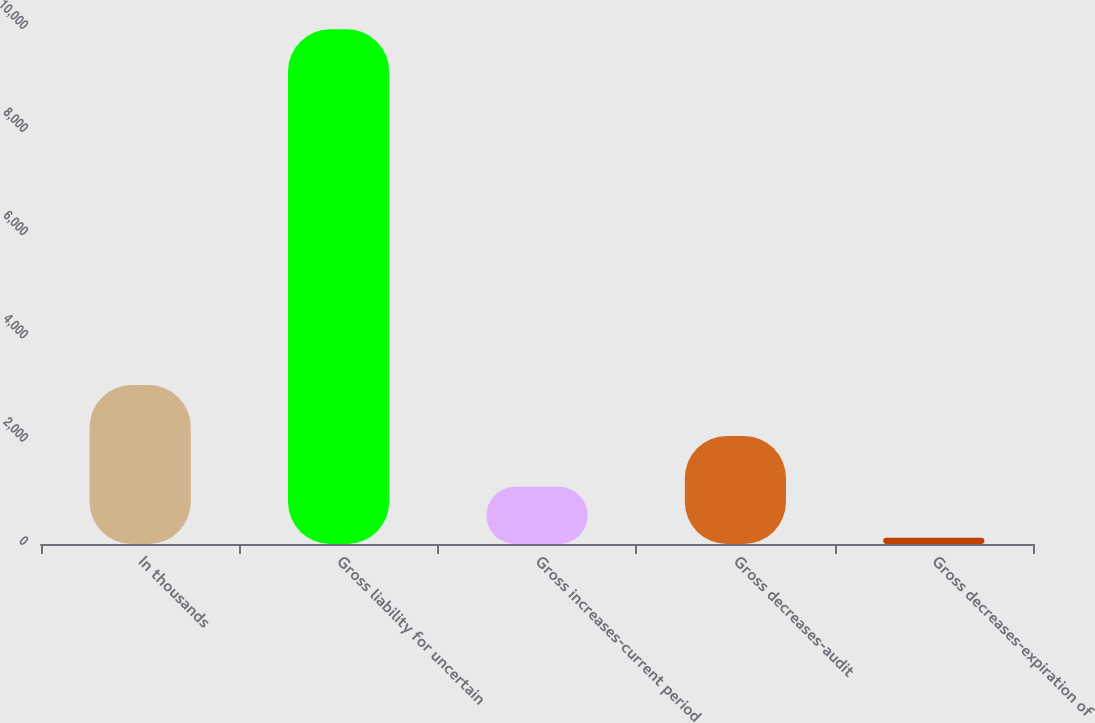<chart> <loc_0><loc_0><loc_500><loc_500><bar_chart><fcel>In thousands<fcel>Gross liability for uncertain<fcel>Gross increases-current period<fcel>Gross decreases-audit<fcel>Gross decreases-expiration of<nl><fcel>3079.7<fcel>9974<fcel>1107.9<fcel>2093.8<fcel>122<nl></chart> 